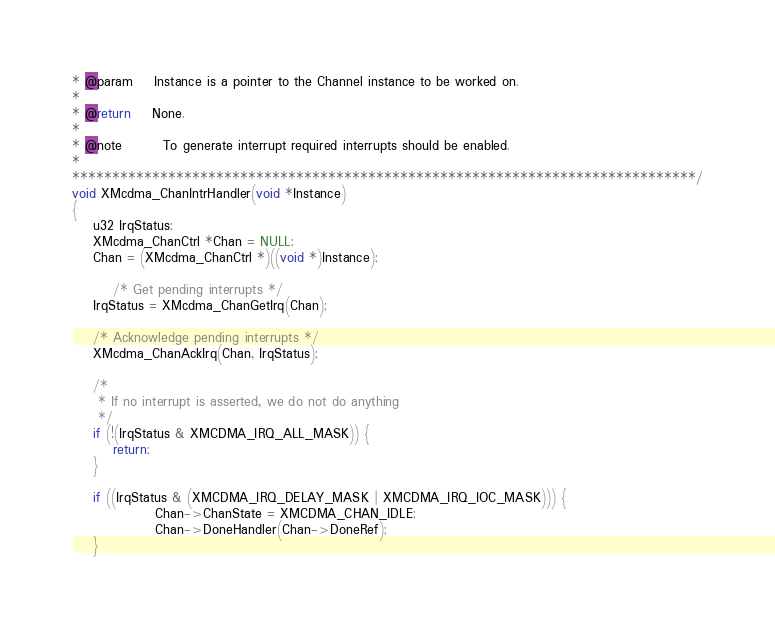<code> <loc_0><loc_0><loc_500><loc_500><_C_>* @param	Instance is a pointer to the Channel instance to be worked on.
*
* @return	None.
*
* @note		To generate interrupt required interrupts should be enabled.
*
******************************************************************************/
void XMcdma_ChanIntrHandler(void *Instance)
{
	u32 IrqStatus;
	XMcdma_ChanCtrl *Chan = NULL;
	Chan = (XMcdma_ChanCtrl *)((void *)Instance);

        /* Get pending interrupts */
	IrqStatus = XMcdma_ChanGetIrq(Chan);

	/* Acknowledge pending interrupts */
	XMcdma_ChanAckIrq(Chan, IrqStatus);

	/*
	 * If no interrupt is asserted, we do not do anything
	 */
	if (!(IrqStatus & XMCDMA_IRQ_ALL_MASK)) {
		return;
	}

	if ((IrqStatus & (XMCDMA_IRQ_DELAY_MASK | XMCDMA_IRQ_IOC_MASK))) {
                Chan->ChanState = XMCDMA_CHAN_IDLE;
                Chan->DoneHandler(Chan->DoneRef);
	}
</code> 